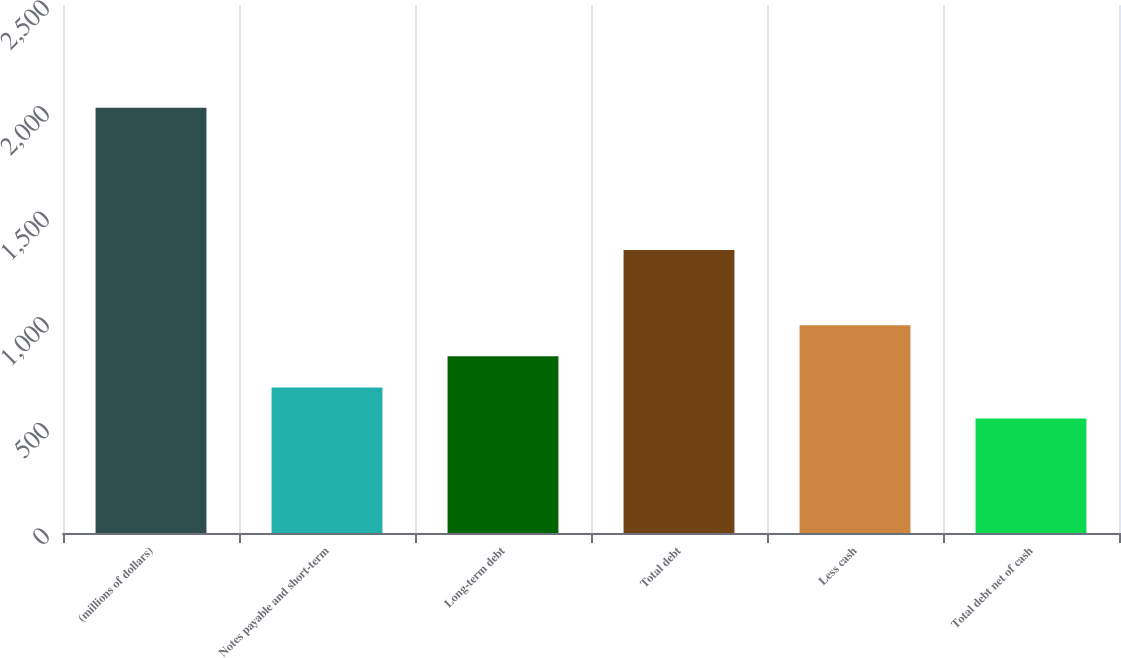Convert chart. <chart><loc_0><loc_0><loc_500><loc_500><bar_chart><fcel>(millions of dollars)<fcel>Notes payable and short-term<fcel>Long-term debt<fcel>Total debt<fcel>Less cash<fcel>Total debt net of cash<nl><fcel>2014<fcel>689.38<fcel>836.56<fcel>1340<fcel>983.74<fcel>542.2<nl></chart> 